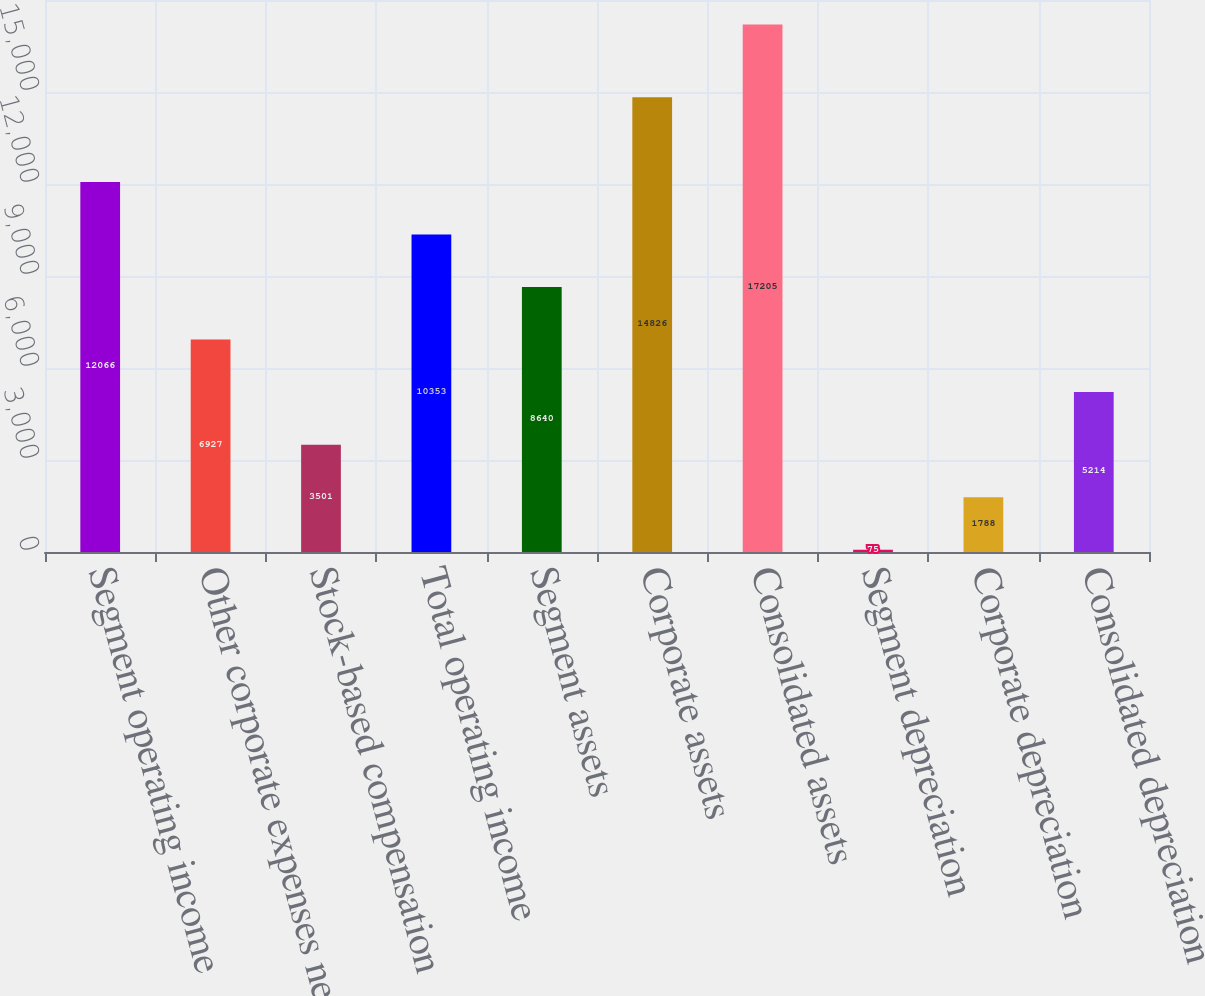<chart> <loc_0><loc_0><loc_500><loc_500><bar_chart><fcel>Segment operating income<fcel>Other corporate expenses net<fcel>Stock-based compensation<fcel>Total operating income<fcel>Segment assets<fcel>Corporate assets<fcel>Consolidated assets<fcel>Segment depreciation<fcel>Corporate depreciation<fcel>Consolidated depreciation<nl><fcel>12066<fcel>6927<fcel>3501<fcel>10353<fcel>8640<fcel>14826<fcel>17205<fcel>75<fcel>1788<fcel>5214<nl></chart> 